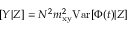<formula> <loc_0><loc_0><loc_500><loc_500>[ Y | Z ] = N ^ { 2 } m _ { x y } ^ { 2 } { V a r } [ \Phi ( t ) | Z ]</formula> 